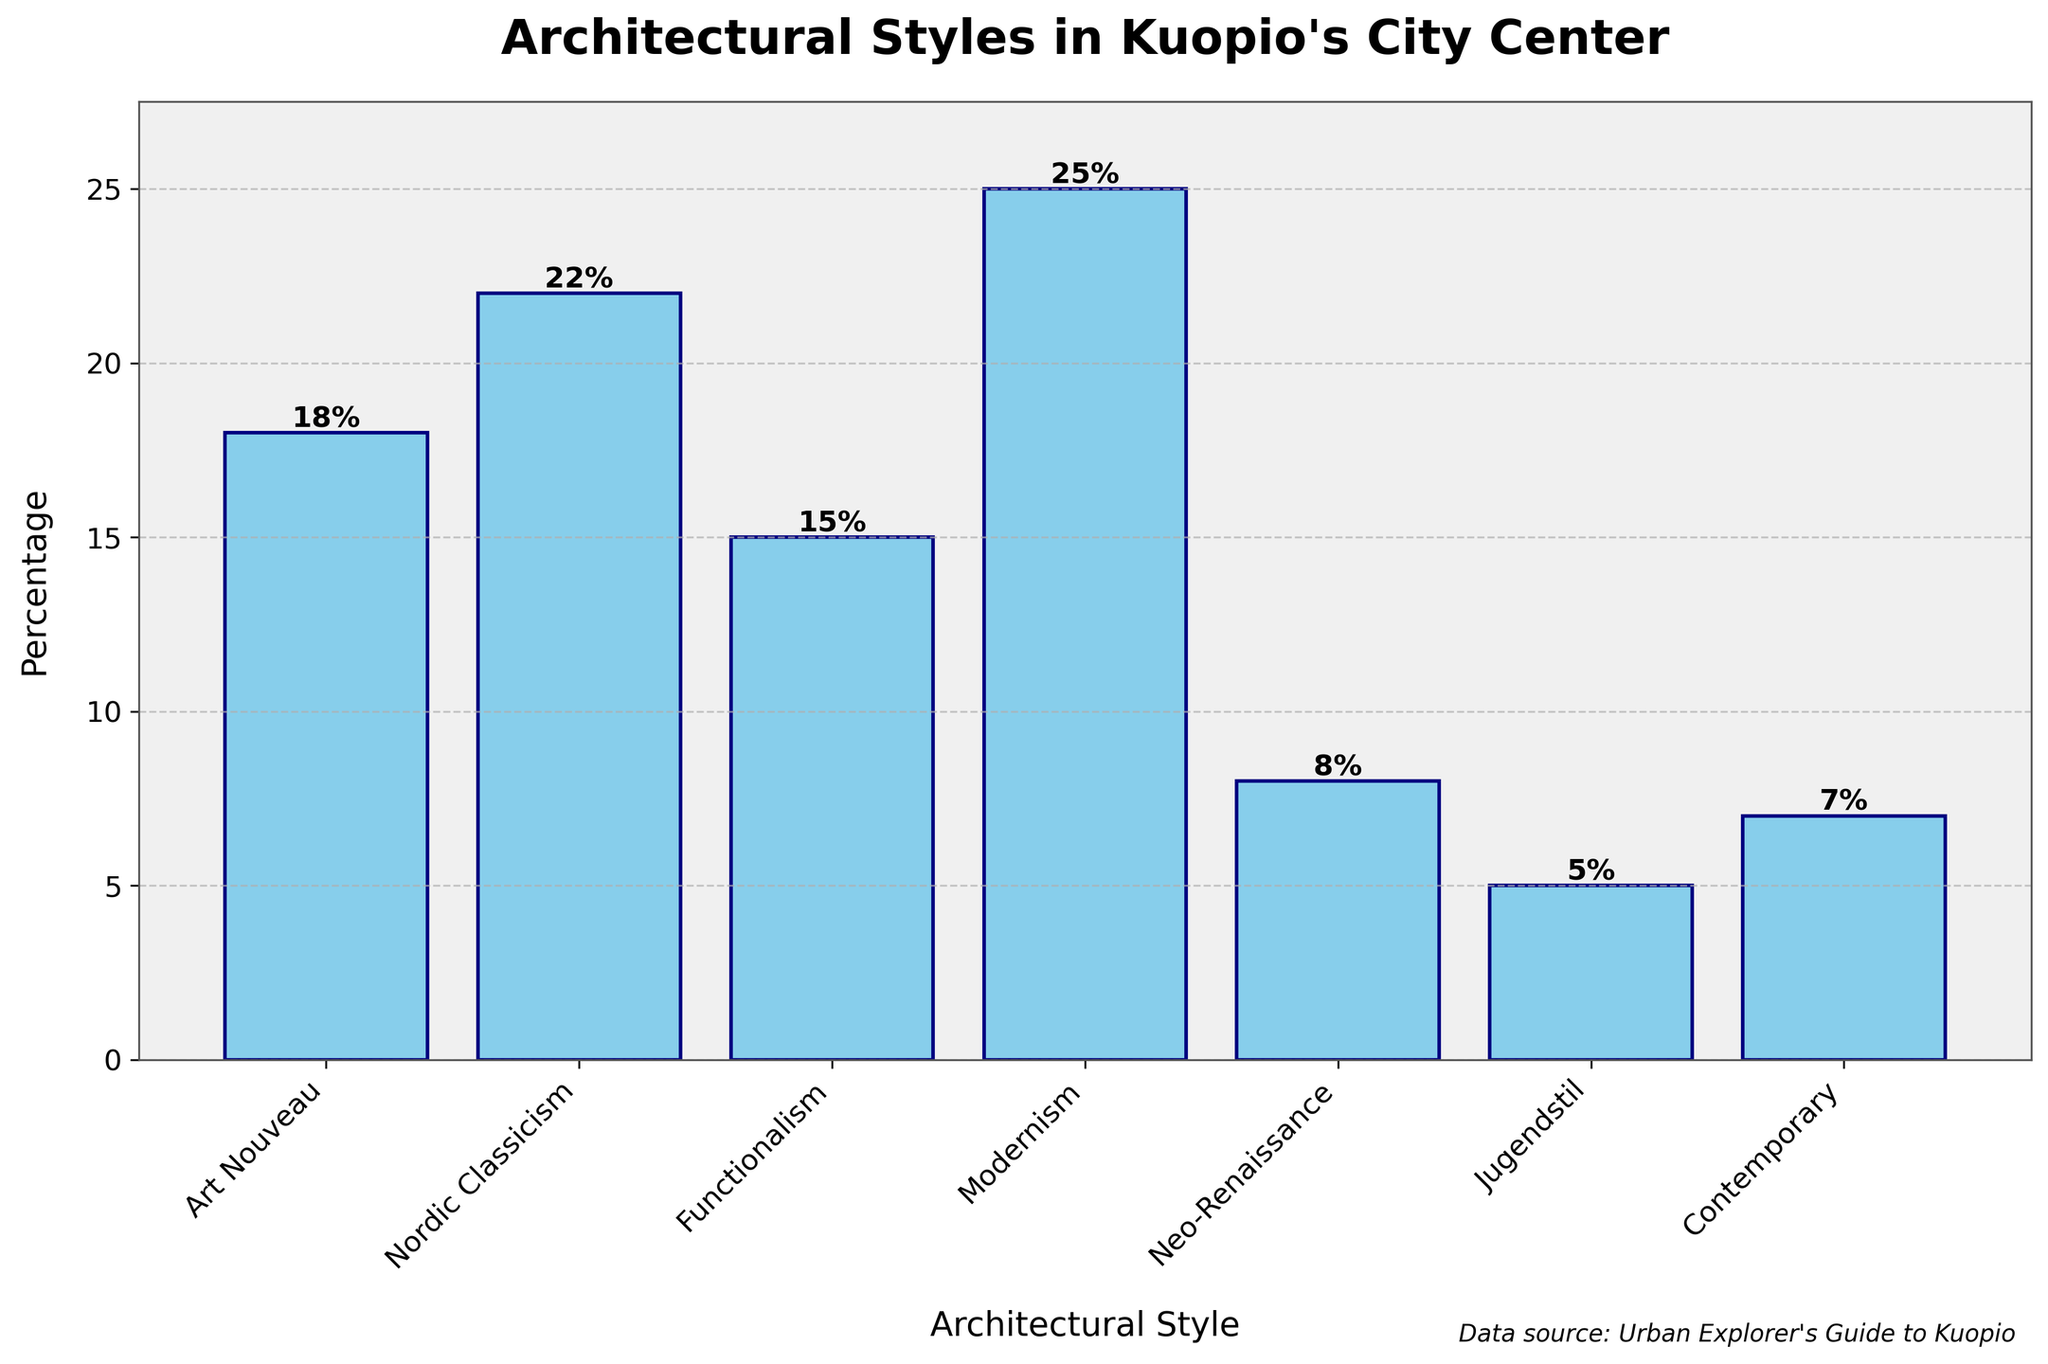What's the most common architectural style in Kuopio's city center? The bar representing Modernism is the tallest, indicating it has the highest percentage.
Answer: Modernism Which architectural style has the smallest percentage? The bar for Jugendstil is the shortest, indicating it has the smallest percentage.
Answer: Jugendstil How much higher is the percentage of Nordic Classicism compared to Contemporary? The bar for Nordic Classicism shows 22%, and the bar for Contemporary shows 7%, so the difference is 22 - 7 = 15%.
Answer: 15% What is the combined percentage of Art Nouveau and Functionalism? The bar for Art Nouveau shows 18%, and the bar for Functionalism shows 15%, so their combined percentage is 18 + 15 = 33%.
Answer: 33% How many architectural styles have a percentage of 20% or higher? The bars for Nordic Classicism (22%), Modernism (25%), and Art Nouveau (18%) show percentages of 20% or higher. There are 2 styles: Nordic Classicism and Modernism.
Answer: 2 Is the percentage of Modernism more than double that of Jugendstil? The bar for Modernism shows 25%, and the bar for Jugendstil shows 5%. Since 25 is more than double 5 (25 > 2*5), the answer is yes.
Answer: Yes What is the average percentage of all architectural styles shown in the plot? The percentages are [18, 22, 15, 25, 8, 5, 7]. The sum of these percentages is 18 + 22 + 15 + 25 + 8 + 5 + 7 = 100. The average is 100 / 7 ≈ 14.29%.
Answer: ≈14.29% How many architectural styles have a percentage less than 10%? The bars for Neo-Renaissance (8%), Jugendstil (5%), and Contemporary (7%) show percentages less than 10%, so there are 3 styles.
Answer: 3 What is the height difference between the bars representing Neo-Renaissance and Art Nouveau? The bar for Neo-Renaissance shows 8%, and the bar for Art Nouveau shows 18%. The difference is 18 - 8 = 10%.
Answer: 10% Which architectural style is represented in the middle if the styles are ranked by percentage? Ranking the styles by percentage: [Jugendstil (5%), Contemporary (7%), Neo-Renaissance (8%), Functionalism (15%), Art Nouveau (18%), Nordic Classicism (22%), Modernism (25%)], the middle style is Functionalism.
Answer: Functionalism 